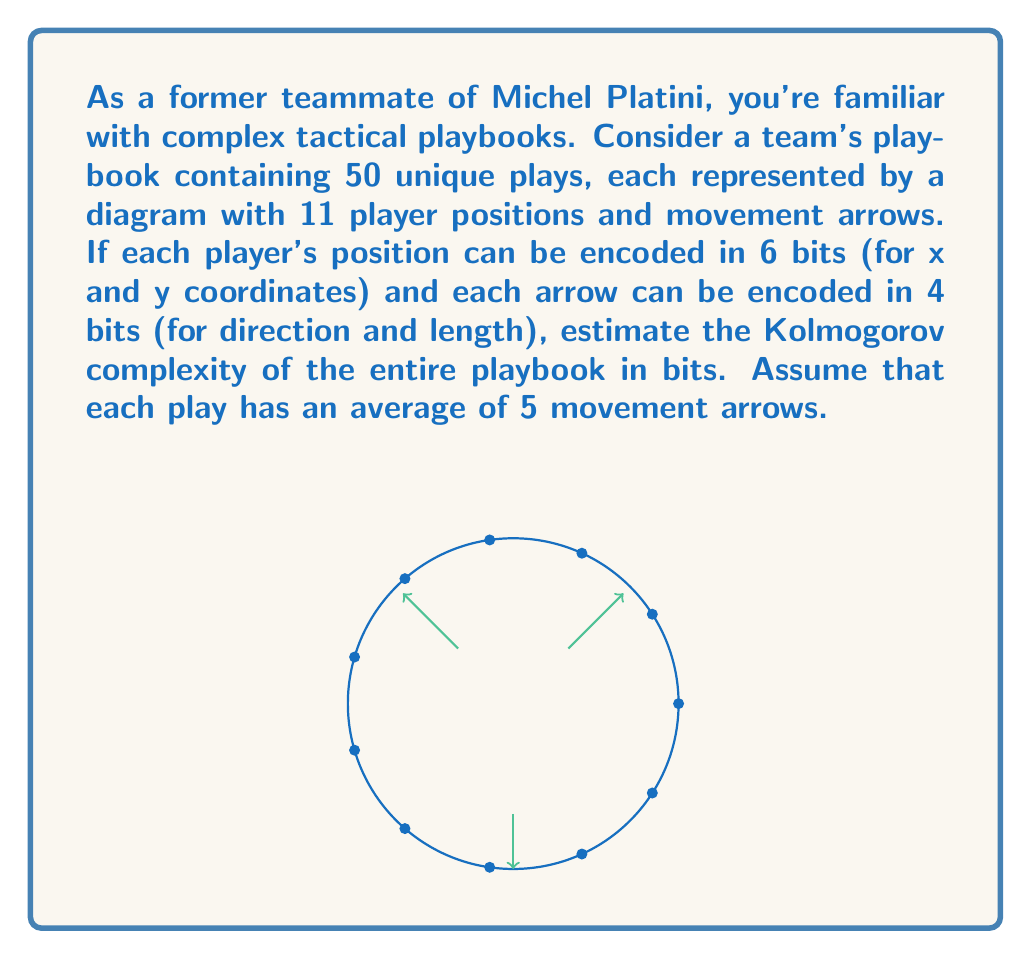Teach me how to tackle this problem. Let's break this down step-by-step:

1) First, let's calculate the bits needed for one play:
   - Player positions: 11 players × 6 bits = 66 bits
   - Arrows: 5 arrows × 4 bits = 20 bits
   - Total for one play: 66 + 20 = 86 bits

2) Now, for the entire playbook with 50 plays:
   $50 \times 86 = 4300$ bits

3) However, the Kolmogorov complexity is about the shortest possible description. We can likely compress this information:

   a) Player positions might have patterns (e.g., standard formations)
   b) Arrows might follow common patterns

4) A rough estimate for compression could be around 50% (this is an assumption based on common data compression ratios)

5) So, our estimate for the Kolmogorov complexity would be:
   $$K(\text{playbook}) \approx 4300 \times 0.5 = 2150 \text{ bits}$$

6) This is equivalent to about 269 bytes, which seems reasonable for a concise description of 50 tactical plays.

Note: The actual Kolmogorov complexity could be lower if there are more patterns to exploit, or higher if the plays are very unique and complex.
Answer: $\approx 2150$ bits 